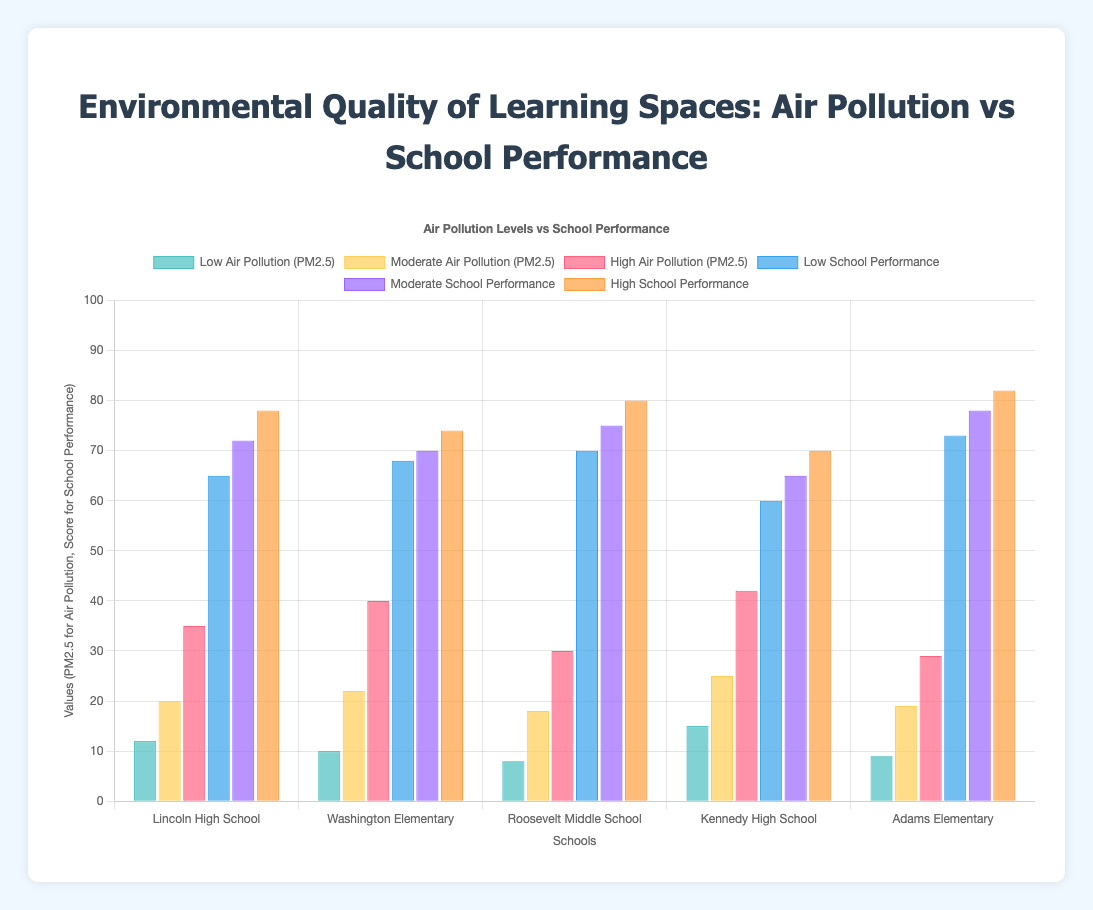Which school has the highest air pollution levels (PM2.5)? Based on the data, we need to compare the highest values for each school’s air pollution levels. Lincoln High School has the highest PM2.5 level at 42.
Answer: Kennedy High School How does the school performance at Adams Elementary under high pollution compare to Roosevelt Middle School under high pollution? Adams Elementary’s high pollution school performance is 82, while Roosevelt Middle School’s high pollution school performance is 80.
Answer: Adams Elementary has a higher performance What's the difference in moderate air pollution levels between Lincoln High School and Roosevelt Middle School? The moderate air pollution level at Lincoln High School is 20 and at Roosevelt Middle School is 18. The difference is 20 - 18.
Answer: 2 Compare the increase in school performance from low to high pollution levels at Kennedy High School. At Kennedy High School, the performance at low pollution is 60, and at high pollution is 70. The increase is 70 - 60.
Answer: 10 Which school shows the least variation in school performance across different air pollution levels? The variations need to be calculated for each school. Adams Elementary: 82 - 73 = 9, Kennedy High School: 70 - 60 = 10, Roosevelt Middle School: 80 - 70 = 10, Washington Elementary: 74 - 68 = 6, Lincoln High School: 78 - 65 = 13.
Answer: Washington Elementary What is the total air pollution level across all three categories (low, moderate, high) for Washington Elementary? Add the PM2.5 values for low (10), moderate (22), and high (40) at Washington Elementary. The total is 10 + 22 + 40.
Answer: 72 Which school has the best performance under low pollution conditions? Compare the low pollution performance scores for all schools: Lincoln High School (65), Washington Elementary (68), Roosevelt Middle School (70), Kennedy High School (60), Adams Elementary (73).
Answer: Adams Elementary What is the average moderate school performance across all schools? Sum the moderate school performance values for all schools (72 + 70 + 75 + 65 + 78) and divide by the number of schools (5). (72 + 70 + 75 + 65 + 78) / 5 = 360 / 5.
Answer: 72 Compare the air pollution levels (high category) and school performance (high category) for Lincoln High School and calculate the absolute difference. Lincoln High School has a high PM2.5 level of 35 and a high school performance of 78. The difference is 78 - 35.
Answer: 43 What is the range of school performances under moderate air pollution across all schools? Determine the maximum and minimum school performance values under moderate air pollution: Max (78 at Adams Elementary), Min (65 at Kennedy High School). The range is 78 - 65.
Answer: 13 